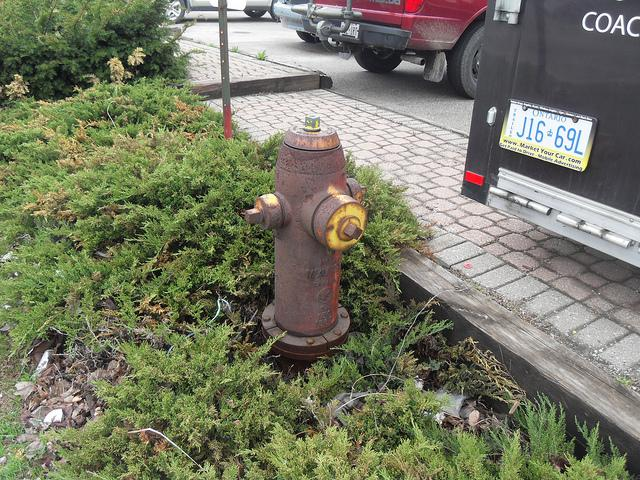Where is the fire hydrant mounted? Please explain your reasoning. landscape. A fire hydrant is surrounded by bushes near the sidewalk. 